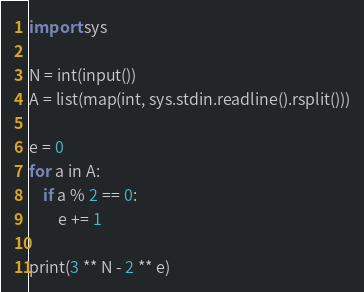Convert code to text. <code><loc_0><loc_0><loc_500><loc_500><_Python_>import sys

N = int(input())
A = list(map(int, sys.stdin.readline().rsplit()))

e = 0
for a in A:
    if a % 2 == 0:
        e += 1 

print(3 ** N - 2 ** e)
</code> 